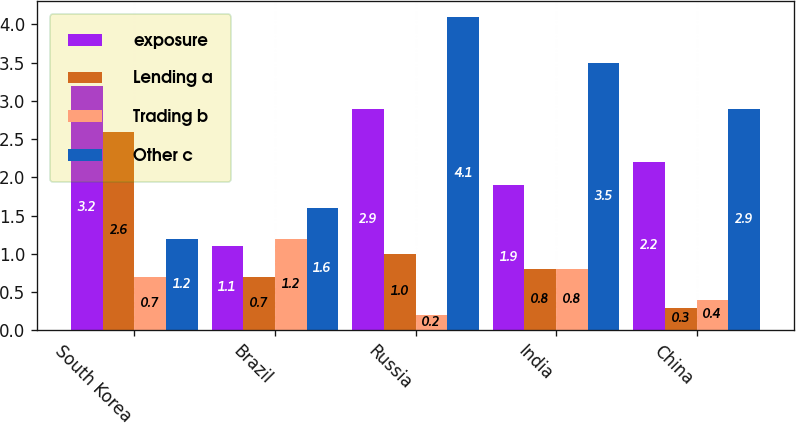Convert chart. <chart><loc_0><loc_0><loc_500><loc_500><stacked_bar_chart><ecel><fcel>South Korea<fcel>Brazil<fcel>Russia<fcel>India<fcel>China<nl><fcel>exposure<fcel>3.2<fcel>1.1<fcel>2.9<fcel>1.9<fcel>2.2<nl><fcel>Lending a<fcel>2.6<fcel>0.7<fcel>1<fcel>0.8<fcel>0.3<nl><fcel>Trading b<fcel>0.7<fcel>1.2<fcel>0.2<fcel>0.8<fcel>0.4<nl><fcel>Other c<fcel>1.2<fcel>1.6<fcel>4.1<fcel>3.5<fcel>2.9<nl></chart> 